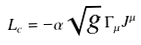<formula> <loc_0><loc_0><loc_500><loc_500>L _ { c } = - \alpha \sqrt { g } \, \Gamma _ { \mu } J ^ { \mu } \,</formula> 